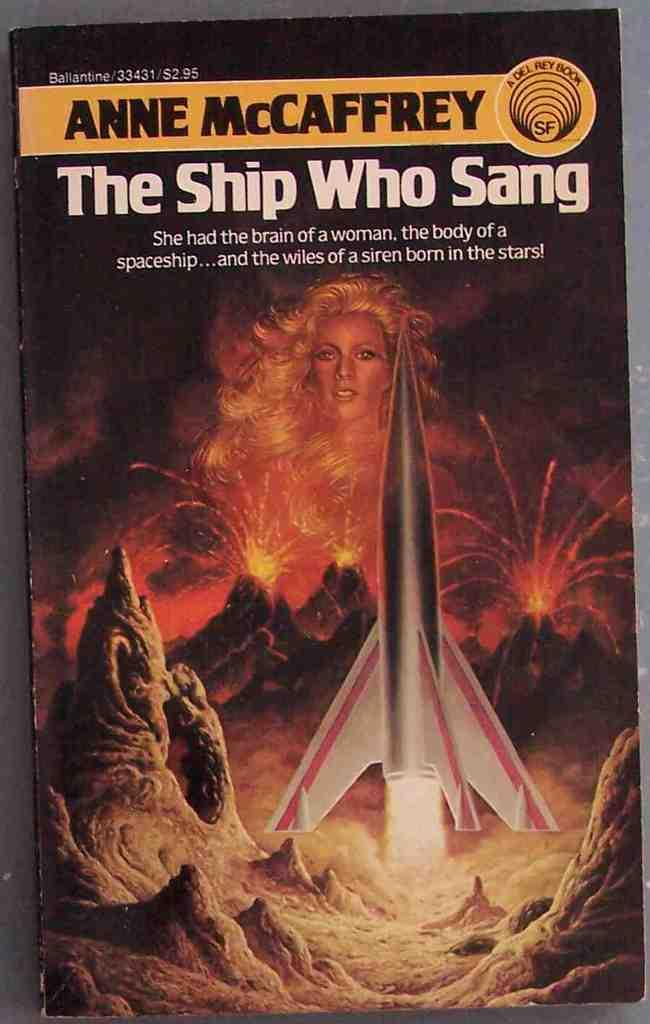<image>
Write a terse but informative summary of the picture. A woman is seen in a picture behind a rocket ship and volcanoes on a book called "The Ship Who Sang". 